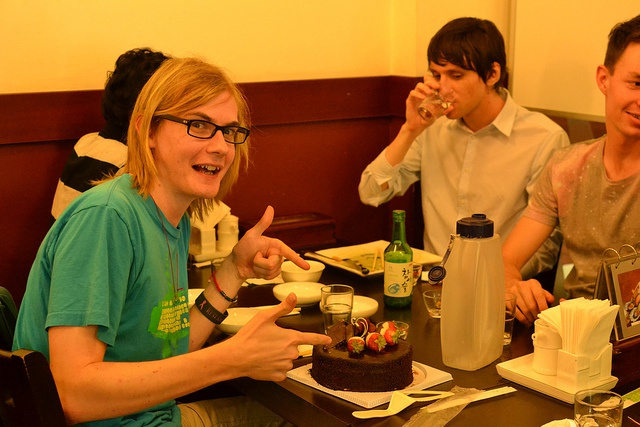Describe the objects in this image and their specific colors. I can see people in orange, red, green, and darkgreen tones, dining table in orange, maroon, black, and olive tones, people in orange and red tones, people in orange, red, and maroon tones, and bottle in orange and black tones in this image. 